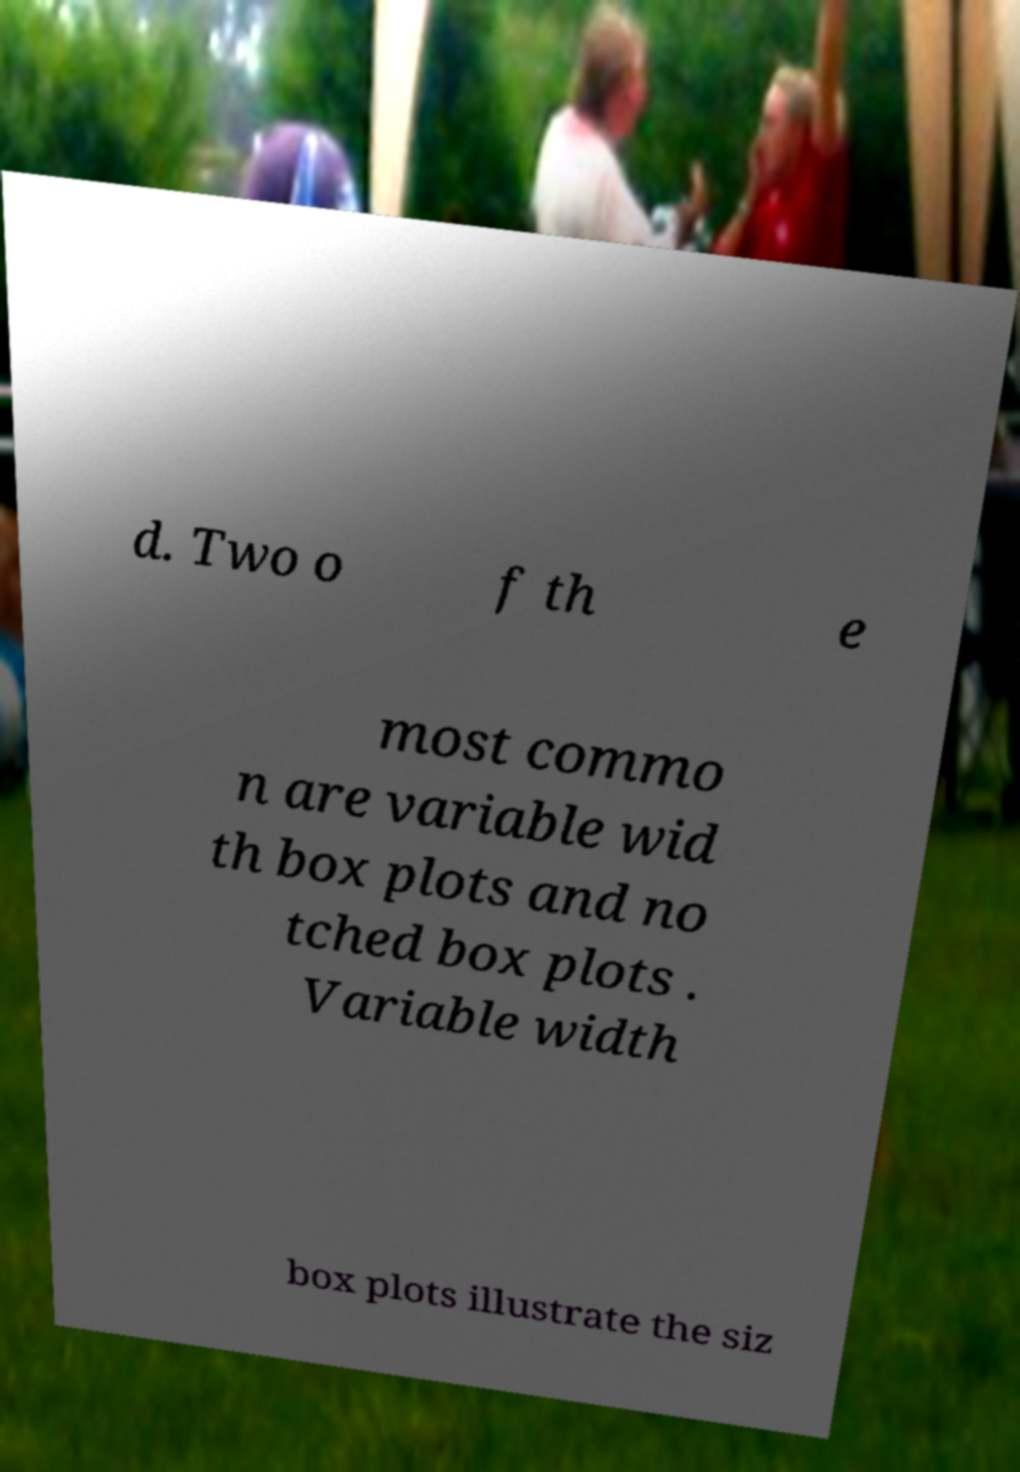For documentation purposes, I need the text within this image transcribed. Could you provide that? d. Two o f th e most commo n are variable wid th box plots and no tched box plots . Variable width box plots illustrate the siz 